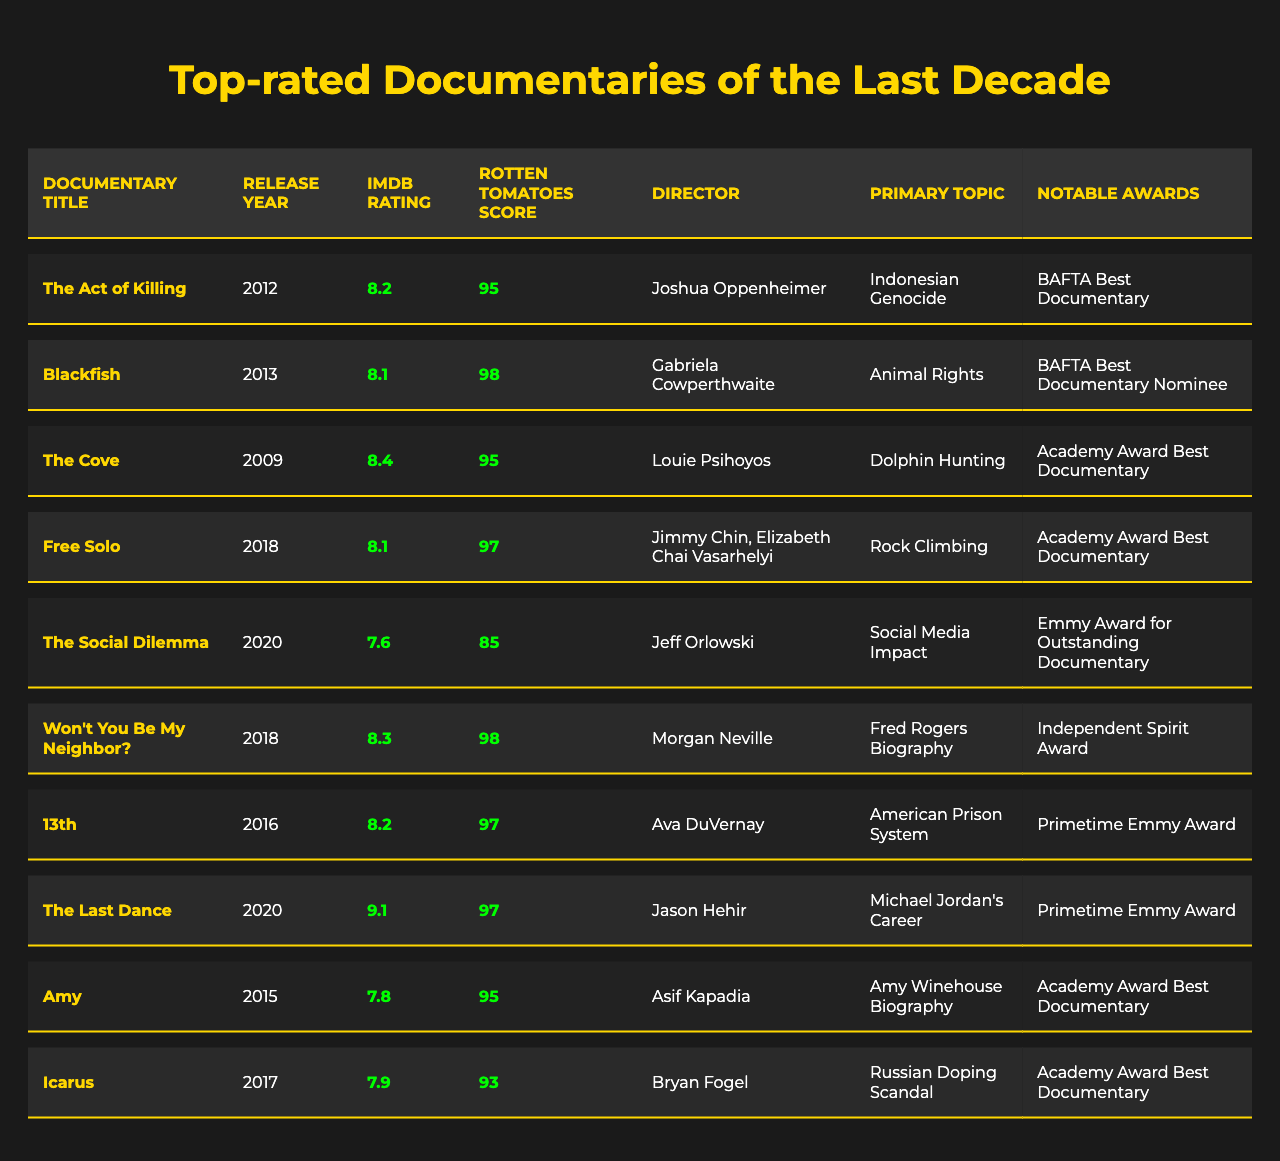What is the highest IMDb rating among the documentaries listed? By reviewing the IMDb Rating column in the table, I see that the highest IMDb rating is 9.1, which corresponds to "The Last Dance."
Answer: 9.1 Which documentary won the Academy Award for Best Documentary? I will look at the Notable Awards column to find any documentary that mentions the Academy Award for Best Documentary. "The Cove," "Free Solo," and "Icarus" all won this award.
Answer: The Cove, Free Solo, Icarus How many documentaries have a Rotten Tomatoes score of 95 or above? I will check the Rotten Tomatoes Score column for documentaries rated 95 or higher. The documentaries are "The Act of Killing," "Blackfish," "The Cove," "Free Solo," "Won't You Be My Neighbor?", "13th," "The Last Dance," "Amy," and "Icarus," totaling 8 documentaries.
Answer: 8 Which director has made a documentary about the American prison system? The only documentary that focuses on the American prison system is "13th," directed by Ava DuVernay.
Answer: Ava DuVernay What is the average IMDb rating of the documentaries released between 2015 and 2020? To find the average, I will sum the IMDb ratings for each documentary released in that period: 7.8 (Amy) + 8.2 (13th) + 7.6 (The Social Dilemma) + 8.3 (Won't You Be My Neighbor?) + 9.1 (The Last Dance) = 41. The number of documentaries is 5, so the average is 41 / 5 = 8.2.
Answer: 8.2 Is "Blackfish" directed by the same person as "The Act of Killing"? I will check the Directors column for both documentaries: "Blackfish" is directed by Gabriela Cowperthwaite and "The Act of Killing" is directed by Joshua Oppenheimer. They are directed by different individuals.
Answer: No What is the difference between the highest and lowest Rotten Tomatoes scores in the table? The highest Rotten Tomatoes score is 98 (from "Blackfish" and "Won't You Be My Neighbor?"), and the lowest is 85 ("The Social Dilemma"). The difference is 98 - 85 = 13.
Answer: 13 Which documentary has the topic of animal rights and what is its IMDb rating? Looking at the Primary Topic column, "Blackfish" addresses animal rights and has an IMDb rating of 8.1.
Answer: Blackfish, 8.1 